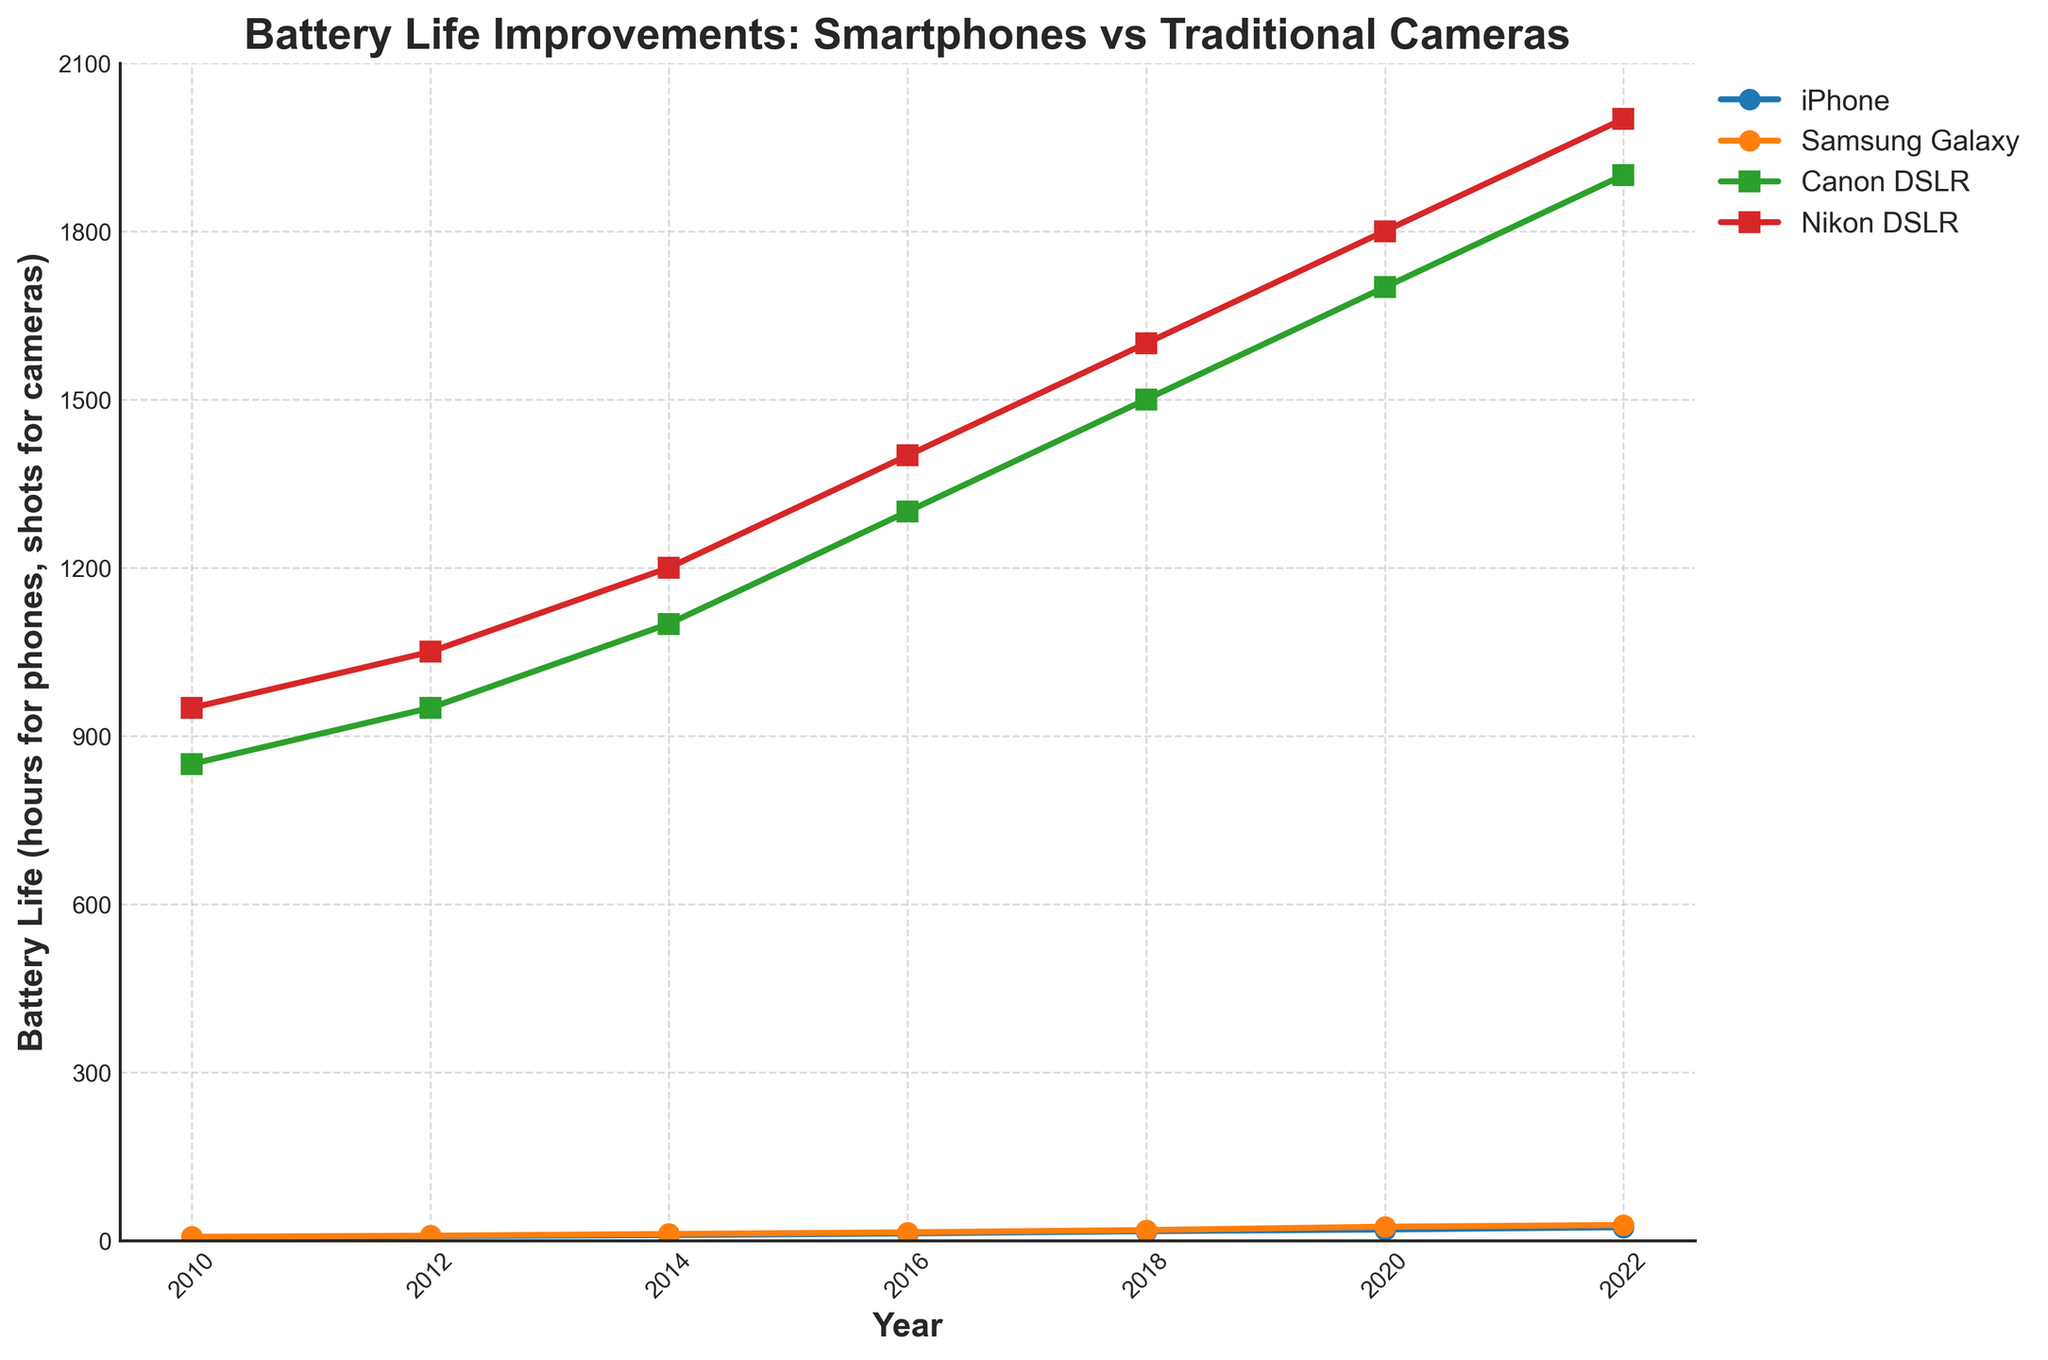What is the range of battery life improvement for the iPhone between 2010 and 2022? To find the range of battery life improvement, subtract the lowest value from the highest value. For the iPhone, the lowest battery life in 2010 was 6 hours, and the highest in 2022 was 24 hours. Therefore, the range is 24 - 6 = 18 hours.
Answer: 18 hours Between 2010 and 2022, which year had the greatest improvement in battery life for the Nikon DSLR compared to the previous recording year? To determine the greatest improvement, calculate the difference in battery life from one recording year to the next and find the maximum difference. For Nikon DSLR: (1050-950 in 2012), (1200-1050 in 2014), (1400-1200 in 2016), (1600-1400 in 2018), (1800-1600 in 2020), (2000-1800 in 2022). The greatest improvement is 200, which occurred from 2010 to 2012 and from 2020 to 2022.
Answer: 2012, 2022 What was the average battery life of the Canon DSLR between 2010 and 2022? To find the average, sum the battery life values for all the years and divide by the number of years. Canon DSLR: (850+950+1100+1300+1500+1700+1900) = 8300. The number of years is 7. Thus, the average is 8300 / 7 ≈ 1186 shots.
Answer: 1186 shots Which device had the highest battery life improvement between any two consecutive years across all years? To find this, calculate the year-over-year change for each device and compare. The iPhone had its largest increase from 2018 to 2020 (3 hours), Samsung Galaxy from 2018 to 2020 (6 hours), Canon DSLR from 2018 to 2020 (200 shots), and Nikon DSLR from 2020 to 2022 (200 shots). Nikon DSLR from 2020 to 2022 had the largest improvement.
Answer: Nikon DSLR from 2020 to 2022 By how many hours did the battery life of the Samsung Galaxy improve from 2010 to 2022? Subtract the 2010 value from the 2022 value for the Samsung Galaxy. The battery life in 2010 was 7 hours, and in 2022, it was 28 hours. Thus, 28 - 7 = 21 hours.
Answer: 21 hours What is the difference in battery life between Canon DSLR and Nikon DSLR in 2016? Subtract the battery life of the Canon DSLR from the Nikon DSLR in 2016. In 2016, Canon DSLR = 1300 shots, and Nikon DSLR = 1400 shots. The difference is 1400 - 1300 = 100 shots.
Answer: 100 shots Between 2010 and 2022, which smartphone showed greater overall improvement in battery life, iPhone or Samsung Galaxy? To determine this, calculate the total improvement for each device. iPhone: 24 - 6 = 18 hours. Samsung Galaxy: 28 - 7 = 21 hours. Samsung Galaxy showed greater improvement.
Answer: Samsung Galaxy By what percentage did the Nikon DSLR battery life improve from 2010 to 2022? Calculate the percentage improvement using the formula ((final value - initial value) / initial value) * 100. For Nikon DSLR: ((2000 - 950) / 950) * 100 ≈ 110.53%.
Answer: 110.53% Which device showed more consistent improvement in battery life over the years, Canon DSLR or Nikon DSLR? To determine consistency, observe the yearly gains. Canon DSLR gains: 100, 150, 200, 200, 200, 200. Nikon DSLR gains: 100, 150, 200, 200, 200. Both devices show consistent improvements, but Canon DSLR starts with a slightly smaller initial gain (100 vs. 100, 150 vs. 150, etc.), indicating Canon DSLR has slightly consistent increments.
Answer: Canon DSLR 